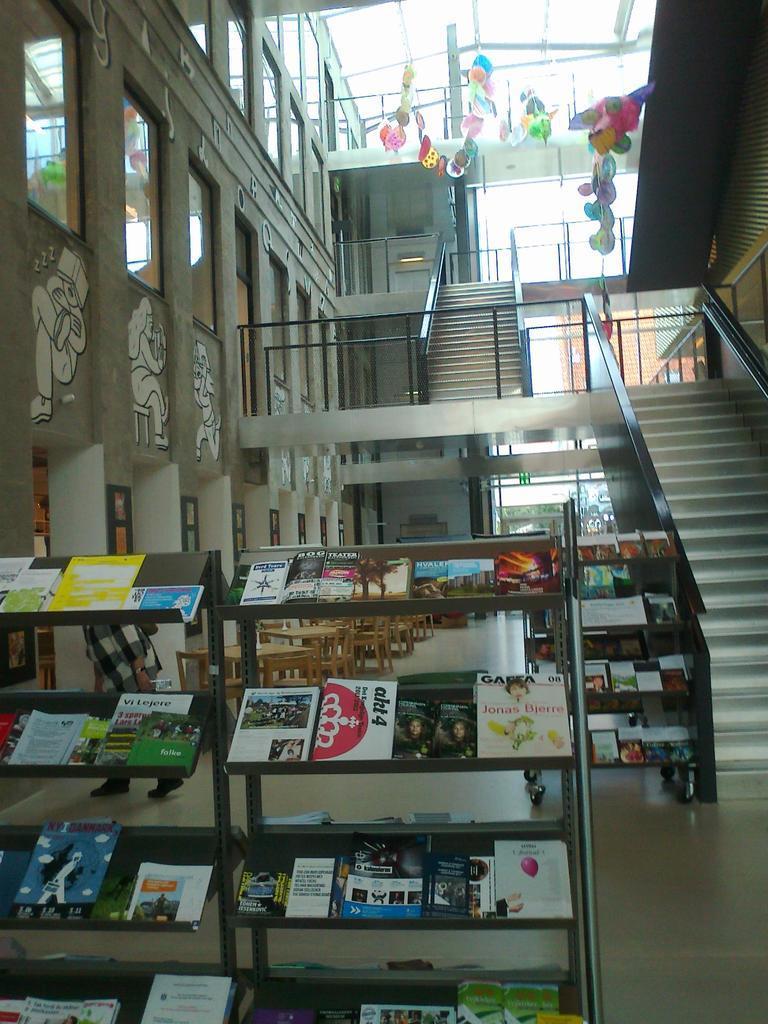Can you describe this image briefly? As we can see in the image there is wall, curtains, stairs and rack filled with books. 